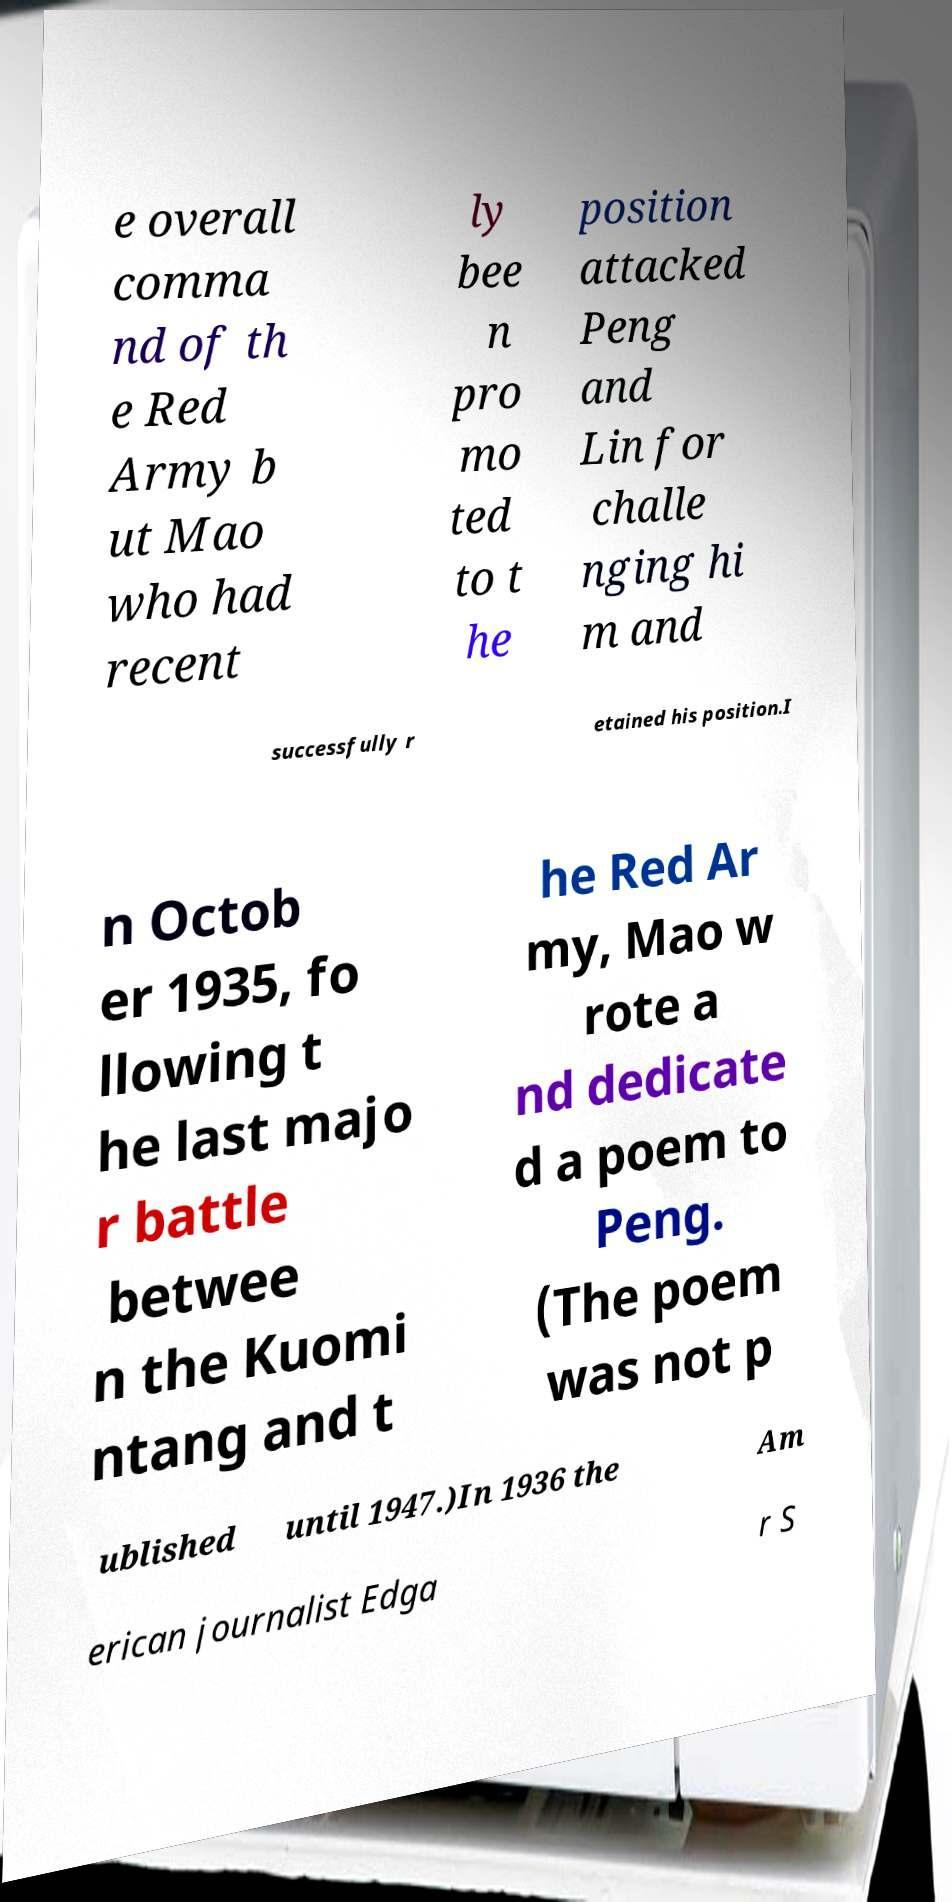Could you extract and type out the text from this image? e overall comma nd of th e Red Army b ut Mao who had recent ly bee n pro mo ted to t he position attacked Peng and Lin for challe nging hi m and successfully r etained his position.I n Octob er 1935, fo llowing t he last majo r battle betwee n the Kuomi ntang and t he Red Ar my, Mao w rote a nd dedicate d a poem to Peng. (The poem was not p ublished until 1947.)In 1936 the Am erican journalist Edga r S 